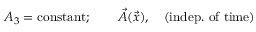<formula> <loc_0><loc_0><loc_500><loc_500>A _ { 3 } = c o n s t a n t ; \quad \vec { A } ( \vec { x } ) , \quad ( i n d e p . o f t i m e )</formula> 